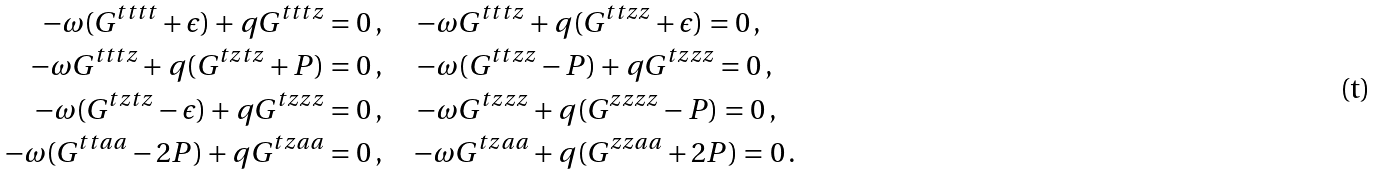<formula> <loc_0><loc_0><loc_500><loc_500>- \omega ( G ^ { t t t t } + \epsilon ) + q G ^ { t t t z } & = 0 \, , \quad \, - \omega G ^ { t t t z } + q ( G ^ { t t z z } + \epsilon ) = 0 \, , \\ - \omega G ^ { t t t z } + q ( G ^ { t z t z } + P ) & = 0 \, , \quad \, - \omega ( G ^ { t t z z } - P ) + q G ^ { t z z z } = 0 \, , \\ - \omega ( G ^ { t z t z } - \epsilon ) + q G ^ { t z z z } & = 0 \, , \quad \, - \omega G ^ { t z z z } + q ( G ^ { z z z z } - P ) = 0 \, , \\ - \omega ( G ^ { t t a a } - 2 P ) + q G ^ { t z a a } & = 0 \, , \quad - \omega G ^ { t z a a } + q ( G ^ { z z a a } + 2 P ) = 0 \, .</formula> 